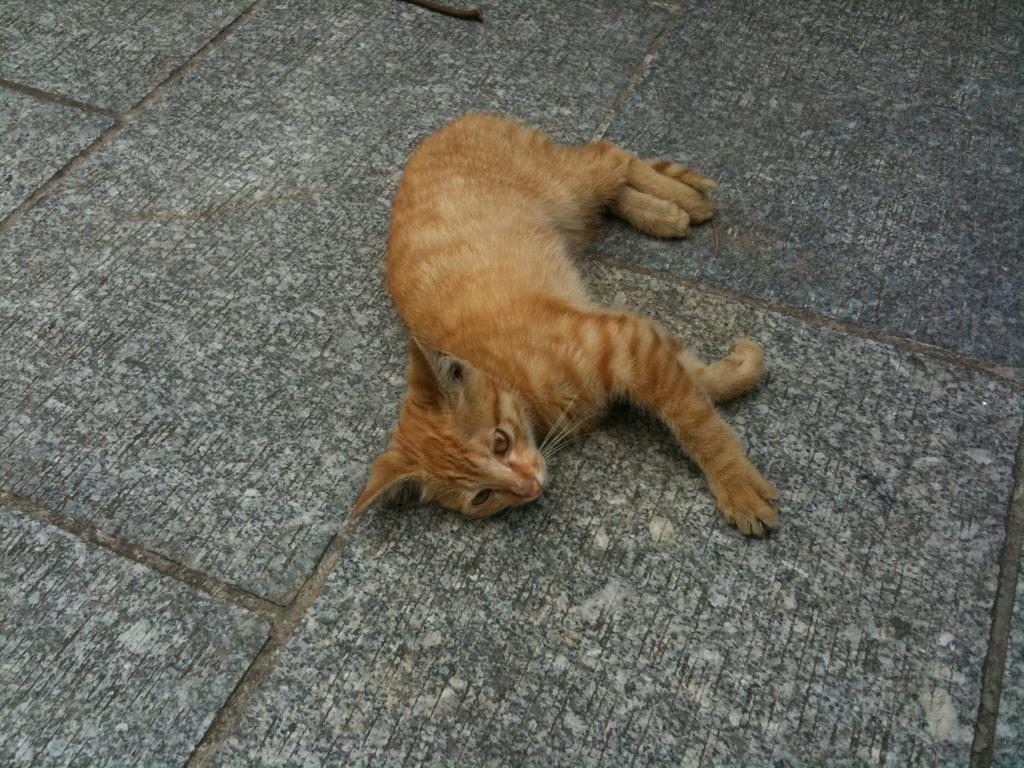What type of animal is present in the image? There is a cat in the image. What is the cat doing in the image? The cat is laying on the floor. Reasoning: Let's think step by step by step in order to produce the conversation. We start by identifying the main subject in the image, which is the cat. Then, we describe the cat's position and activity, which is laying on the floor. Each question is designed to elicit a specific detail about the image that is known from the provided facts. Absurd Question/Answer: What type of boat is the cat sailing in the image? There is no boat present in the image; the cat is laying on the floor. 